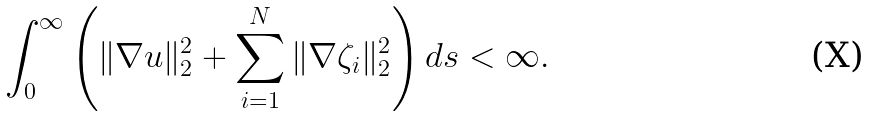Convert formula to latex. <formula><loc_0><loc_0><loc_500><loc_500>\int _ { 0 } ^ { \infty } \left ( \| \nabla u \| _ { 2 } ^ { 2 } + \sum _ { i = 1 } ^ { N } \| \nabla \zeta _ { i } \| _ { 2 } ^ { 2 } \right ) d s < \infty .</formula> 